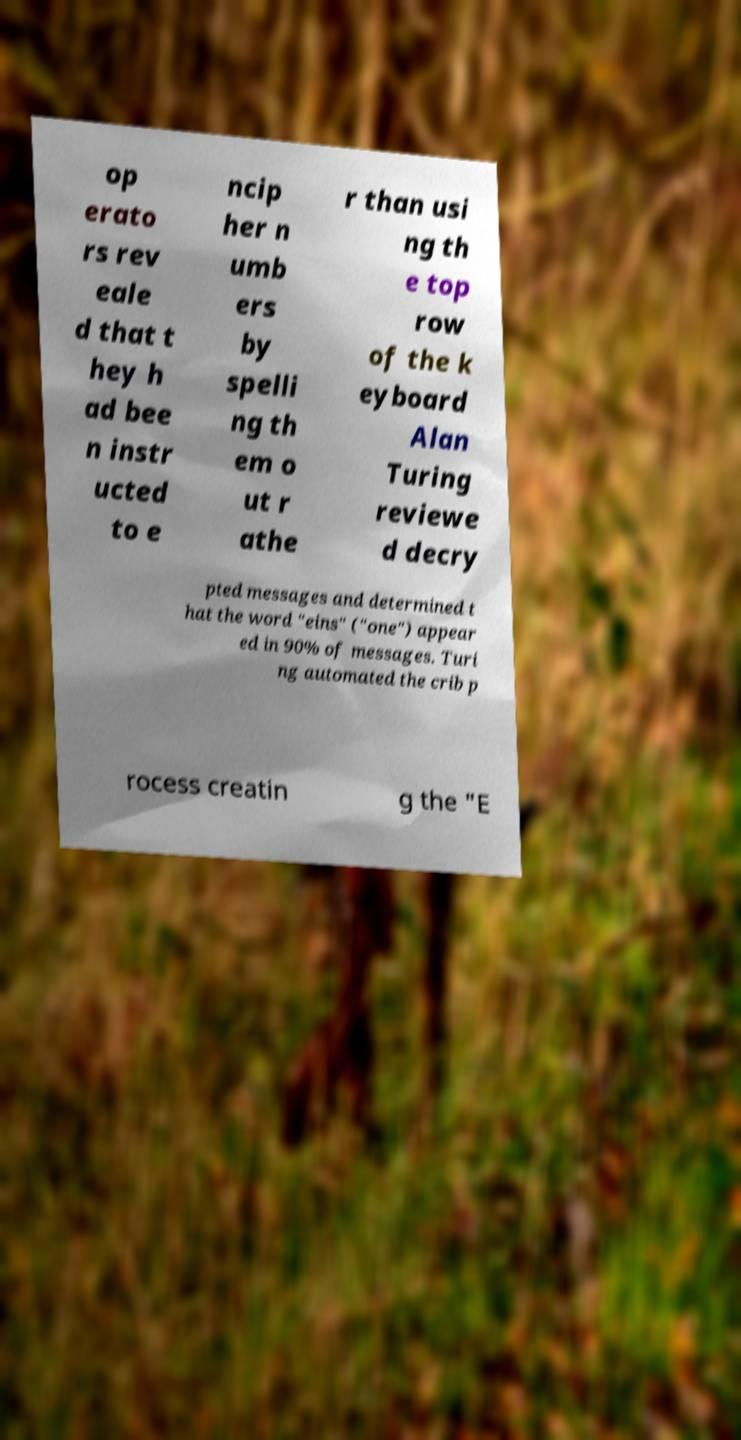Can you accurately transcribe the text from the provided image for me? op erato rs rev eale d that t hey h ad bee n instr ucted to e ncip her n umb ers by spelli ng th em o ut r athe r than usi ng th e top row of the k eyboard Alan Turing reviewe d decry pted messages and determined t hat the word "eins" ("one") appear ed in 90% of messages. Turi ng automated the crib p rocess creatin g the "E 